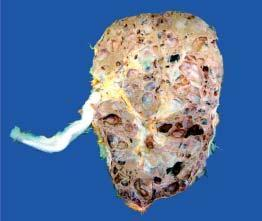what shows loss of demarcation between cortex and medulla and replacement of the entire renal parenchyma by cyst s varying in diameter from a few millimeters to 4-5 cm?
Answer the question using a single word or phrase. Sectioned surface 